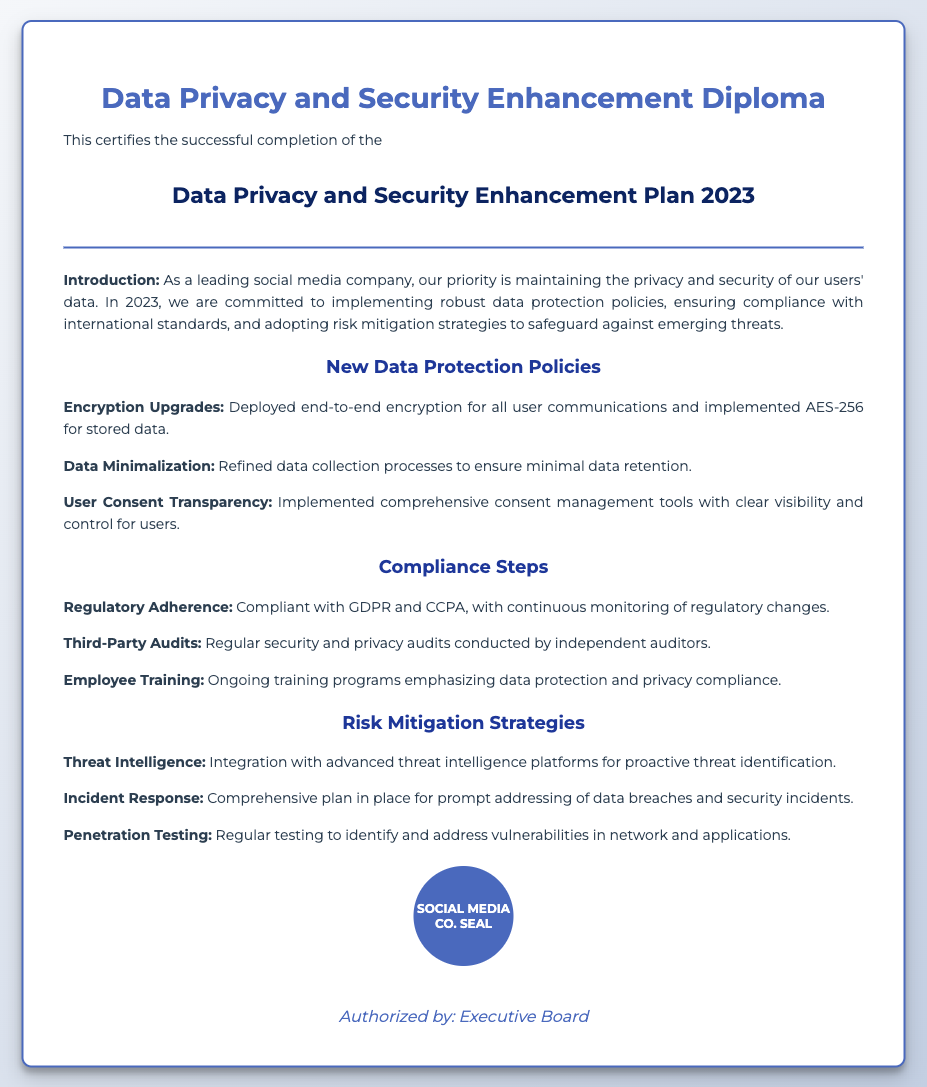what is the title of the diploma? The title of the diploma is specified in the document as "Data Privacy and Security Enhancement Diploma."
Answer: Data Privacy and Security Enhancement Diploma who is authorized by the document? The document states that it is authorized by the "Executive Board."
Answer: Executive Board what standard does the company comply with? The document mentions compliance with GDPR and CCPA.
Answer: GDPR and CCPA what type of encryption is used for stored data? The document indicates that AES-256 is the encryption used for stored data.
Answer: AES-256 what training is provided to employees? The document outlines that there are "ongoing training programs" for data protection and privacy compliance.
Answer: ongoing training programs how is threat identification achieved? The document mentions integration with "advanced threat intelligence platforms."
Answer: advanced threat intelligence platforms what is one strategy mentioned for incident response? The document states there is a "comprehensive plan in place" for addressing data breaches and security incidents.
Answer: comprehensive plan in place how often are third-party audits conducted? The document does not specify a frequency for third-party audits but mentions they are "regular."
Answer: regular what is the focus of the new data protection policies? The focus of the new data protection policies emphasizes user privacy and data security in the document.
Answer: user privacy and data security 